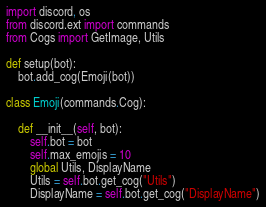Convert code to text. <code><loc_0><loc_0><loc_500><loc_500><_Python_>import discord, os
from discord.ext import commands
from Cogs import GetImage, Utils

def setup(bot):
    bot.add_cog(Emoji(bot))

class Emoji(commands.Cog):

    def __init__(self, bot):
        self.bot = bot
        self.max_emojis = 10
        global Utils, DisplayName
        Utils = self.bot.get_cog("Utils")
        DisplayName = self.bot.get_cog("DisplayName")</code> 